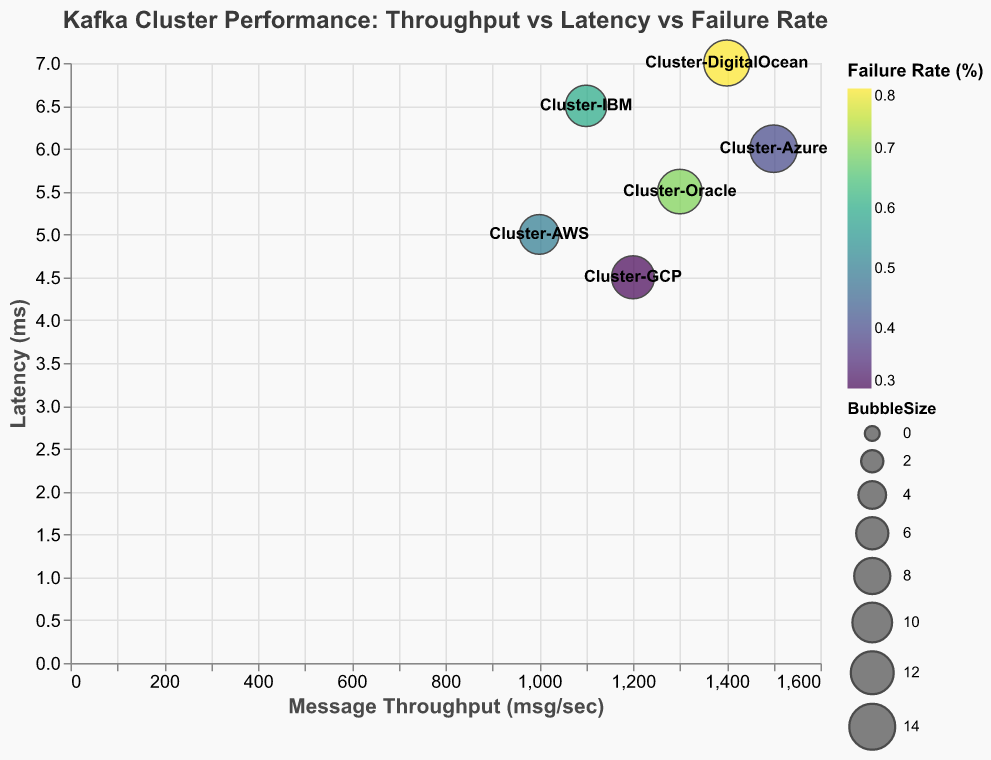What is the title of the plot? The title of the plot is typically displayed at the top and provides a concise description of what the plot represents. In this case, it reads "Kafka Cluster Performance: Throughput vs Latency vs Failure Rate".
Answer: Kafka Cluster Performance: Throughput vs Latency vs Failure Rate How many clusters are plotted in the figure? Each bubble on the plot represents a Kafka Cluster, and there are 6 different bubbles, hence there are 6 clusters plotted.
Answer: 6 Which cluster has the highest failure rate? By inspecting the color intensity of the bubbles, which corresponds to the failure rate, the darkest bubble indicates the highest failure rate. Cluster-DigitalOcean has the highest failure rate of 0.8%.
Answer: Cluster-DigitalOcean Which cluster has the lowest latency? By looking at the y-axis and finding the bubble that is lowest on the plot, Cluster-GCP has the lowest latency of 4.5ms.
Answer: Cluster-GCP What is the average latency across all clusters? To find the average latency, sum up all latency values and divide by the number of clusters. Calculations: (5 + 6 + 4.5 + 6.5 + 5.5 + 7) / 6 = 34.5 / 6 = 5.75 ms.
Answer: 5.75 ms How does Cluster-IBM's latency compare to Cluster-Azure's latency? Looking at the y-axis positions of Cluster-IBM and Cluster-Azure, Cluster-IBM has a latency of 6.5 ms which is higher than Cluster-Azure's latency of 6 ms.
Answer: Cluster-IBM's latency is higher Which cluster has the highest throughput? By looking at the x-axis, the furthest bubble to the right represents the highest throughput. Cluster-Azure has the highest throughput of 1500 msg/sec.
Answer: Cluster-Azure What is the relationship between latency and failure rate among the clusters? Analyzing the colors and their corresponding positions on the y-axis shows that clusters with higher latency tend to have higher failure rates, like Cluster-DigitalOcean with 7ms latency and 0.8% failure rate.
Answer: Higher latency generally correlates with a higher failure rate What does the bubble size represent in the plot? The bubble size represents the message throughput for each cluster, with larger bubbles indicating higher throughput. The specific size of bubbles increases with throughput.
Answer: Message throughput If we want to reduce the failure rate, which cluster appears to be the most reliable choice based on this plot? By looking at the color gradient for failure rates, Cluster-GCP has the lightest color indicating the lowest failure rate of 0.3%. Thus, Cluster-GCP seems to be the most reliable choice.
Answer: Cluster-GCP 